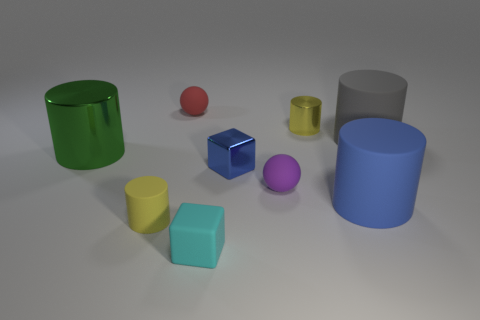Subtract all gray matte cylinders. How many cylinders are left? 4 Subtract all cyan blocks. How many blocks are left? 1 Subtract all cylinders. How many objects are left? 4 Subtract 1 cubes. How many cubes are left? 1 Subtract all red cylinders. Subtract all yellow cubes. How many cylinders are left? 5 Subtract all brown cubes. How many gray cylinders are left? 1 Subtract all small cyan matte things. Subtract all yellow cylinders. How many objects are left? 6 Add 5 tiny cyan objects. How many tiny cyan objects are left? 6 Add 2 cyan rubber blocks. How many cyan rubber blocks exist? 3 Subtract 0 blue balls. How many objects are left? 9 